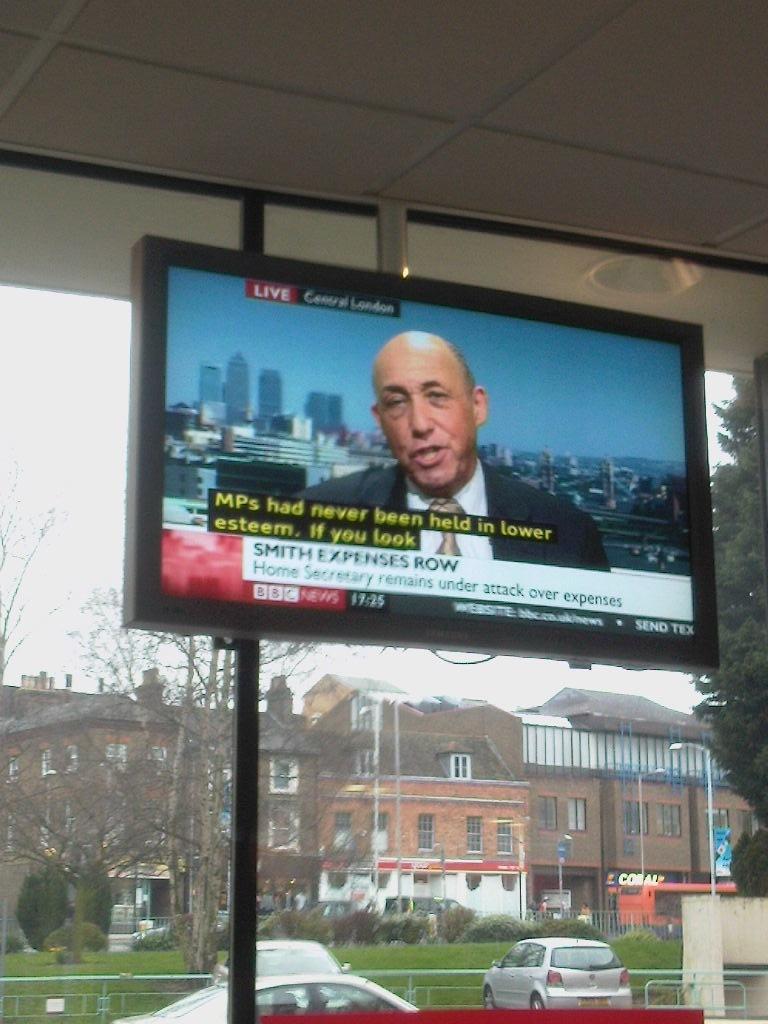What does smith do?
Your response must be concise. Expenses row. 